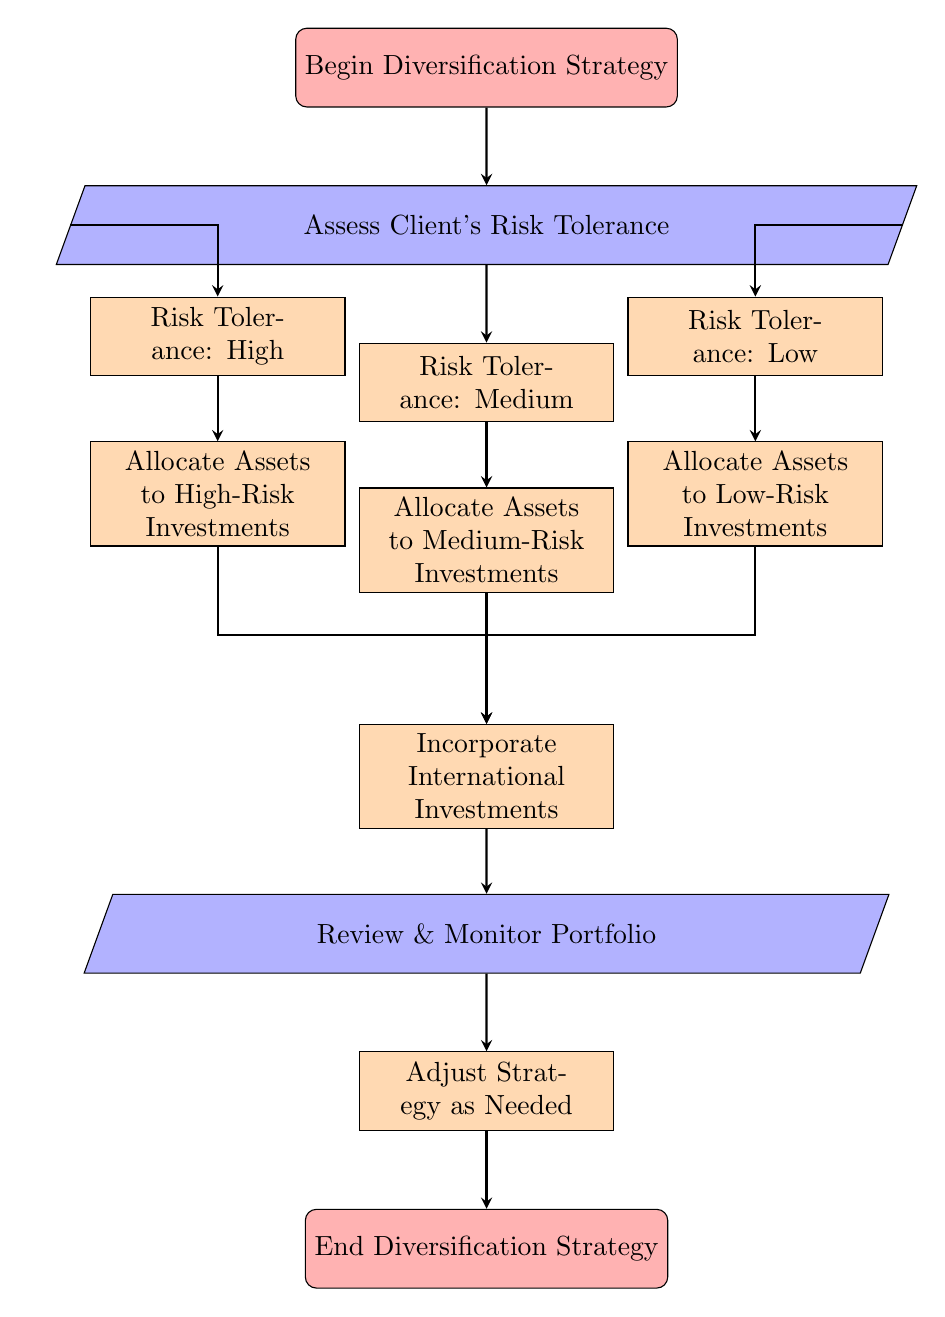What is the first step in the diversification strategy? The first step is indicated by the node labeled "Begin Diversification Strategy," which starts the flow of the chart.
Answer: Begin Diversification Strategy How many risk tolerance categories are there in the chart? There are three risk tolerance categories: High, Medium, and Low, as shown in the diagram.
Answer: Three What type of investments are allocated when the risk tolerance is medium? For medium risk tolerance, the investments allocated are "Allocate Assets to Medium-Risk Investments," which can include options like balance funds and index funds.
Answer: Allocate Assets to Medium-Risk Investments What happens after allocating assets to any risk level? After allocating assets to any risk level (high, medium, or low), the process moves to "Incorporate International Investments," showing that this step follows allocation.
Answer: Incorporate International Investments What is the last step in the diversification strategy? The last step of the strategy is depicted in the final node labeled "End Diversification Strategy," which signifies the conclusion of the process.
Answer: End Diversification Strategy What does the diagram illustrate about client assessments? The diagram illustrates that the first action after starting the strategy is to "Assess Client's Risk Tolerance," emphasizing the importance of understanding client needs before proceeding.
Answer: Assess Client's Risk Tolerance How are the international investments incorporated based on risk tolerance? International investments are incorporated regardless of the risk tolerance level, as each risk category (high, medium, low) leads to the step of incorporating international investments afterward.
Answer: International investments are incorporated What is done after reviewing and monitoring the portfolio? After reviewing and monitoring the portfolio, the next step is to "Adjust Strategy as Needed," indicating ongoing management and responsiveness to market conditions.
Answer: Adjust Strategy as Needed 